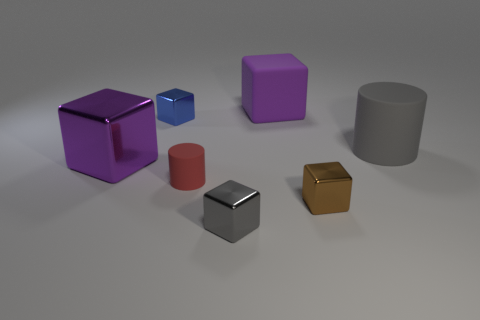Is there a tiny red cylinder that is on the right side of the gray object that is in front of the tiny red cylinder?
Provide a short and direct response. No. Are there any small gray metallic things that are to the right of the gray object that is in front of the purple thing on the left side of the small red object?
Your answer should be compact. No. Is the shape of the large purple object to the left of the blue metal object the same as the gray shiny thing in front of the small blue object?
Keep it short and to the point. Yes. What color is the big cylinder that is the same material as the red object?
Give a very brief answer. Gray. Is the number of red rubber objects that are on the right side of the brown thing less than the number of small red objects?
Provide a succinct answer. Yes. What size is the blue metallic cube to the left of the purple object right of the gray block on the right side of the red cylinder?
Offer a very short reply. Small. Are the big purple object that is left of the gray metal cube and the tiny cylinder made of the same material?
Keep it short and to the point. No. There is a large thing that is the same color as the large metal block; what is its material?
Offer a terse response. Rubber. Is there any other thing that is the same shape as the purple matte object?
Your answer should be very brief. Yes. How many things are big brown blocks or rubber objects?
Provide a short and direct response. 3. 